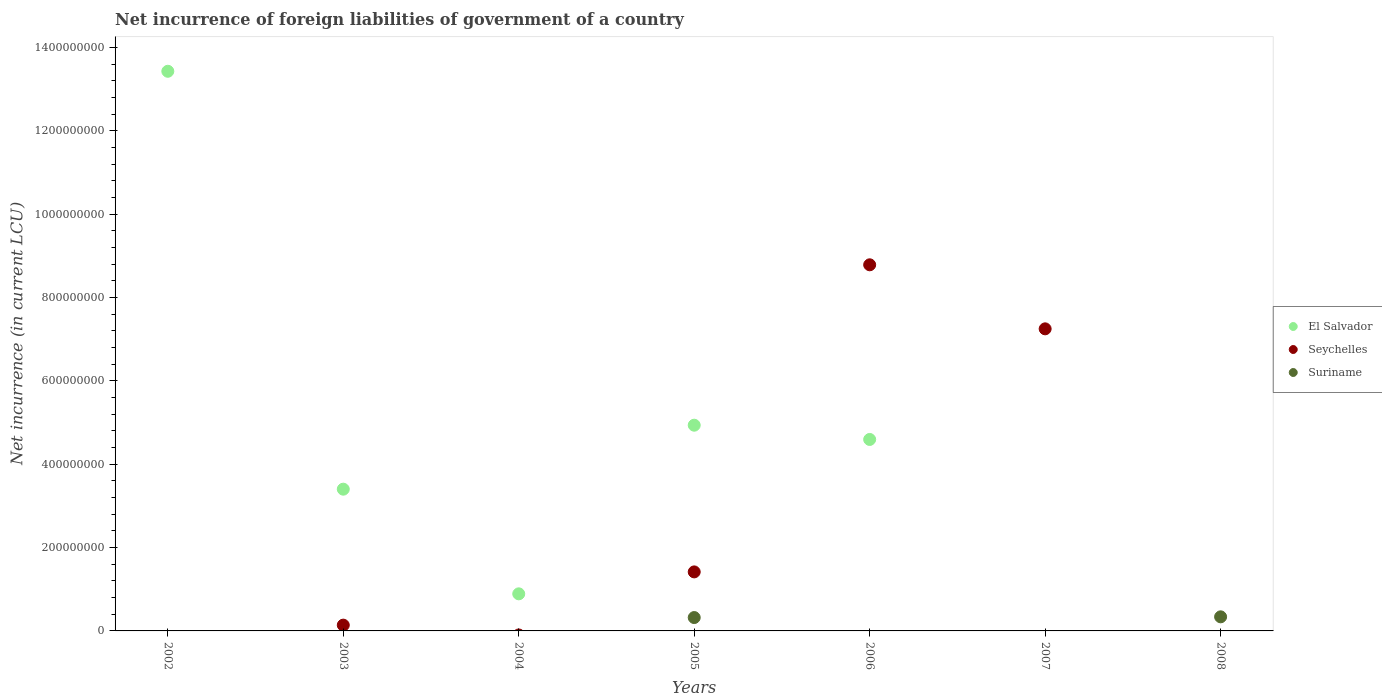Is the number of dotlines equal to the number of legend labels?
Make the answer very short. No. What is the net incurrence of foreign liabilities in Suriname in 2008?
Your answer should be very brief. 3.38e+07. Across all years, what is the maximum net incurrence of foreign liabilities in Seychelles?
Your answer should be compact. 8.78e+08. Across all years, what is the minimum net incurrence of foreign liabilities in Suriname?
Offer a terse response. 0. What is the total net incurrence of foreign liabilities in Seychelles in the graph?
Your response must be concise. 1.76e+09. What is the difference between the net incurrence of foreign liabilities in El Salvador in 2003 and that in 2006?
Provide a succinct answer. -1.19e+08. What is the difference between the net incurrence of foreign liabilities in Suriname in 2006 and the net incurrence of foreign liabilities in El Salvador in 2008?
Provide a short and direct response. 0. What is the average net incurrence of foreign liabilities in El Salvador per year?
Provide a succinct answer. 3.89e+08. In the year 2005, what is the difference between the net incurrence of foreign liabilities in Seychelles and net incurrence of foreign liabilities in Suriname?
Your response must be concise. 1.10e+08. In how many years, is the net incurrence of foreign liabilities in Seychelles greater than 960000000 LCU?
Ensure brevity in your answer.  0. What is the ratio of the net incurrence of foreign liabilities in El Salvador in 2002 to that in 2006?
Provide a succinct answer. 2.92. Is the net incurrence of foreign liabilities in El Salvador in 2003 less than that in 2006?
Ensure brevity in your answer.  Yes. What is the difference between the highest and the second highest net incurrence of foreign liabilities in Seychelles?
Make the answer very short. 1.54e+08. What is the difference between the highest and the lowest net incurrence of foreign liabilities in El Salvador?
Keep it short and to the point. 1.34e+09. In how many years, is the net incurrence of foreign liabilities in Seychelles greater than the average net incurrence of foreign liabilities in Seychelles taken over all years?
Ensure brevity in your answer.  2. Does the net incurrence of foreign liabilities in Seychelles monotonically increase over the years?
Give a very brief answer. No. Is the net incurrence of foreign liabilities in Suriname strictly greater than the net incurrence of foreign liabilities in El Salvador over the years?
Give a very brief answer. No. What is the difference between two consecutive major ticks on the Y-axis?
Make the answer very short. 2.00e+08. Does the graph contain any zero values?
Offer a terse response. Yes. How many legend labels are there?
Your answer should be compact. 3. What is the title of the graph?
Your answer should be compact. Net incurrence of foreign liabilities of government of a country. What is the label or title of the X-axis?
Offer a very short reply. Years. What is the label or title of the Y-axis?
Your answer should be compact. Net incurrence (in current LCU). What is the Net incurrence (in current LCU) of El Salvador in 2002?
Offer a terse response. 1.34e+09. What is the Net incurrence (in current LCU) of El Salvador in 2003?
Keep it short and to the point. 3.40e+08. What is the Net incurrence (in current LCU) in Seychelles in 2003?
Keep it short and to the point. 1.39e+07. What is the Net incurrence (in current LCU) in El Salvador in 2004?
Ensure brevity in your answer.  8.90e+07. What is the Net incurrence (in current LCU) in El Salvador in 2005?
Provide a short and direct response. 4.94e+08. What is the Net incurrence (in current LCU) of Seychelles in 2005?
Your answer should be compact. 1.42e+08. What is the Net incurrence (in current LCU) in Suriname in 2005?
Provide a succinct answer. 3.21e+07. What is the Net incurrence (in current LCU) of El Salvador in 2006?
Ensure brevity in your answer.  4.59e+08. What is the Net incurrence (in current LCU) in Seychelles in 2006?
Offer a very short reply. 8.78e+08. What is the Net incurrence (in current LCU) in El Salvador in 2007?
Your answer should be compact. 0. What is the Net incurrence (in current LCU) in Seychelles in 2007?
Make the answer very short. 7.25e+08. What is the Net incurrence (in current LCU) in Suriname in 2007?
Keep it short and to the point. 0. What is the Net incurrence (in current LCU) of El Salvador in 2008?
Your answer should be very brief. 0. What is the Net incurrence (in current LCU) of Suriname in 2008?
Your response must be concise. 3.38e+07. Across all years, what is the maximum Net incurrence (in current LCU) of El Salvador?
Provide a short and direct response. 1.34e+09. Across all years, what is the maximum Net incurrence (in current LCU) in Seychelles?
Your response must be concise. 8.78e+08. Across all years, what is the maximum Net incurrence (in current LCU) of Suriname?
Make the answer very short. 3.38e+07. Across all years, what is the minimum Net incurrence (in current LCU) of El Salvador?
Ensure brevity in your answer.  0. Across all years, what is the minimum Net incurrence (in current LCU) in Suriname?
Make the answer very short. 0. What is the total Net incurrence (in current LCU) of El Salvador in the graph?
Your response must be concise. 2.72e+09. What is the total Net incurrence (in current LCU) in Seychelles in the graph?
Your response must be concise. 1.76e+09. What is the total Net incurrence (in current LCU) of Suriname in the graph?
Make the answer very short. 6.59e+07. What is the difference between the Net incurrence (in current LCU) of El Salvador in 2002 and that in 2003?
Ensure brevity in your answer.  1.00e+09. What is the difference between the Net incurrence (in current LCU) in El Salvador in 2002 and that in 2004?
Your answer should be very brief. 1.25e+09. What is the difference between the Net incurrence (in current LCU) of El Salvador in 2002 and that in 2005?
Provide a succinct answer. 8.49e+08. What is the difference between the Net incurrence (in current LCU) of El Salvador in 2002 and that in 2006?
Provide a succinct answer. 8.83e+08. What is the difference between the Net incurrence (in current LCU) of El Salvador in 2003 and that in 2004?
Your answer should be very brief. 2.51e+08. What is the difference between the Net incurrence (in current LCU) in El Salvador in 2003 and that in 2005?
Your answer should be very brief. -1.54e+08. What is the difference between the Net incurrence (in current LCU) in Seychelles in 2003 and that in 2005?
Make the answer very short. -1.28e+08. What is the difference between the Net incurrence (in current LCU) of El Salvador in 2003 and that in 2006?
Your response must be concise. -1.19e+08. What is the difference between the Net incurrence (in current LCU) in Seychelles in 2003 and that in 2006?
Give a very brief answer. -8.65e+08. What is the difference between the Net incurrence (in current LCU) of Seychelles in 2003 and that in 2007?
Provide a short and direct response. -7.11e+08. What is the difference between the Net incurrence (in current LCU) of El Salvador in 2004 and that in 2005?
Give a very brief answer. -4.05e+08. What is the difference between the Net incurrence (in current LCU) in El Salvador in 2004 and that in 2006?
Make the answer very short. -3.70e+08. What is the difference between the Net incurrence (in current LCU) of El Salvador in 2005 and that in 2006?
Give a very brief answer. 3.42e+07. What is the difference between the Net incurrence (in current LCU) of Seychelles in 2005 and that in 2006?
Your response must be concise. -7.37e+08. What is the difference between the Net incurrence (in current LCU) in Seychelles in 2005 and that in 2007?
Provide a succinct answer. -5.83e+08. What is the difference between the Net incurrence (in current LCU) of Suriname in 2005 and that in 2008?
Provide a short and direct response. -1.72e+06. What is the difference between the Net incurrence (in current LCU) in Seychelles in 2006 and that in 2007?
Offer a very short reply. 1.54e+08. What is the difference between the Net incurrence (in current LCU) of El Salvador in 2002 and the Net incurrence (in current LCU) of Seychelles in 2003?
Your answer should be compact. 1.33e+09. What is the difference between the Net incurrence (in current LCU) of El Salvador in 2002 and the Net incurrence (in current LCU) of Seychelles in 2005?
Keep it short and to the point. 1.20e+09. What is the difference between the Net incurrence (in current LCU) in El Salvador in 2002 and the Net incurrence (in current LCU) in Suriname in 2005?
Your response must be concise. 1.31e+09. What is the difference between the Net incurrence (in current LCU) of El Salvador in 2002 and the Net incurrence (in current LCU) of Seychelles in 2006?
Provide a succinct answer. 4.64e+08. What is the difference between the Net incurrence (in current LCU) in El Salvador in 2002 and the Net incurrence (in current LCU) in Seychelles in 2007?
Make the answer very short. 6.18e+08. What is the difference between the Net incurrence (in current LCU) of El Salvador in 2002 and the Net incurrence (in current LCU) of Suriname in 2008?
Offer a terse response. 1.31e+09. What is the difference between the Net incurrence (in current LCU) in El Salvador in 2003 and the Net incurrence (in current LCU) in Seychelles in 2005?
Your response must be concise. 1.98e+08. What is the difference between the Net incurrence (in current LCU) in El Salvador in 2003 and the Net incurrence (in current LCU) in Suriname in 2005?
Offer a very short reply. 3.08e+08. What is the difference between the Net incurrence (in current LCU) of Seychelles in 2003 and the Net incurrence (in current LCU) of Suriname in 2005?
Offer a very short reply. -1.82e+07. What is the difference between the Net incurrence (in current LCU) in El Salvador in 2003 and the Net incurrence (in current LCU) in Seychelles in 2006?
Ensure brevity in your answer.  -5.38e+08. What is the difference between the Net incurrence (in current LCU) of El Salvador in 2003 and the Net incurrence (in current LCU) of Seychelles in 2007?
Offer a very short reply. -3.85e+08. What is the difference between the Net incurrence (in current LCU) of El Salvador in 2003 and the Net incurrence (in current LCU) of Suriname in 2008?
Give a very brief answer. 3.06e+08. What is the difference between the Net incurrence (in current LCU) in Seychelles in 2003 and the Net incurrence (in current LCU) in Suriname in 2008?
Make the answer very short. -1.99e+07. What is the difference between the Net incurrence (in current LCU) of El Salvador in 2004 and the Net incurrence (in current LCU) of Seychelles in 2005?
Ensure brevity in your answer.  -5.26e+07. What is the difference between the Net incurrence (in current LCU) in El Salvador in 2004 and the Net incurrence (in current LCU) in Suriname in 2005?
Ensure brevity in your answer.  5.69e+07. What is the difference between the Net incurrence (in current LCU) in El Salvador in 2004 and the Net incurrence (in current LCU) in Seychelles in 2006?
Your response must be concise. -7.89e+08. What is the difference between the Net incurrence (in current LCU) in El Salvador in 2004 and the Net incurrence (in current LCU) in Seychelles in 2007?
Give a very brief answer. -6.36e+08. What is the difference between the Net incurrence (in current LCU) of El Salvador in 2004 and the Net incurrence (in current LCU) of Suriname in 2008?
Your answer should be very brief. 5.52e+07. What is the difference between the Net incurrence (in current LCU) in El Salvador in 2005 and the Net incurrence (in current LCU) in Seychelles in 2006?
Offer a very short reply. -3.85e+08. What is the difference between the Net incurrence (in current LCU) in El Salvador in 2005 and the Net incurrence (in current LCU) in Seychelles in 2007?
Give a very brief answer. -2.31e+08. What is the difference between the Net incurrence (in current LCU) in El Salvador in 2005 and the Net incurrence (in current LCU) in Suriname in 2008?
Your answer should be compact. 4.60e+08. What is the difference between the Net incurrence (in current LCU) of Seychelles in 2005 and the Net incurrence (in current LCU) of Suriname in 2008?
Make the answer very short. 1.08e+08. What is the difference between the Net incurrence (in current LCU) in El Salvador in 2006 and the Net incurrence (in current LCU) in Seychelles in 2007?
Give a very brief answer. -2.65e+08. What is the difference between the Net incurrence (in current LCU) in El Salvador in 2006 and the Net incurrence (in current LCU) in Suriname in 2008?
Keep it short and to the point. 4.26e+08. What is the difference between the Net incurrence (in current LCU) of Seychelles in 2006 and the Net incurrence (in current LCU) of Suriname in 2008?
Offer a very short reply. 8.45e+08. What is the difference between the Net incurrence (in current LCU) in Seychelles in 2007 and the Net incurrence (in current LCU) in Suriname in 2008?
Your answer should be very brief. 6.91e+08. What is the average Net incurrence (in current LCU) in El Salvador per year?
Provide a short and direct response. 3.89e+08. What is the average Net incurrence (in current LCU) in Seychelles per year?
Provide a succinct answer. 2.51e+08. What is the average Net incurrence (in current LCU) of Suriname per year?
Ensure brevity in your answer.  9.41e+06. In the year 2003, what is the difference between the Net incurrence (in current LCU) of El Salvador and Net incurrence (in current LCU) of Seychelles?
Your answer should be compact. 3.26e+08. In the year 2005, what is the difference between the Net incurrence (in current LCU) of El Salvador and Net incurrence (in current LCU) of Seychelles?
Give a very brief answer. 3.52e+08. In the year 2005, what is the difference between the Net incurrence (in current LCU) of El Salvador and Net incurrence (in current LCU) of Suriname?
Provide a short and direct response. 4.62e+08. In the year 2005, what is the difference between the Net incurrence (in current LCU) in Seychelles and Net incurrence (in current LCU) in Suriname?
Your response must be concise. 1.10e+08. In the year 2006, what is the difference between the Net incurrence (in current LCU) in El Salvador and Net incurrence (in current LCU) in Seychelles?
Provide a succinct answer. -4.19e+08. What is the ratio of the Net incurrence (in current LCU) in El Salvador in 2002 to that in 2003?
Provide a short and direct response. 3.95. What is the ratio of the Net incurrence (in current LCU) of El Salvador in 2002 to that in 2004?
Provide a succinct answer. 15.09. What is the ratio of the Net incurrence (in current LCU) of El Salvador in 2002 to that in 2005?
Offer a very short reply. 2.72. What is the ratio of the Net incurrence (in current LCU) of El Salvador in 2002 to that in 2006?
Your answer should be very brief. 2.92. What is the ratio of the Net incurrence (in current LCU) of El Salvador in 2003 to that in 2004?
Keep it short and to the point. 3.82. What is the ratio of the Net incurrence (in current LCU) of El Salvador in 2003 to that in 2005?
Make the answer very short. 0.69. What is the ratio of the Net incurrence (in current LCU) in Seychelles in 2003 to that in 2005?
Give a very brief answer. 0.1. What is the ratio of the Net incurrence (in current LCU) in El Salvador in 2003 to that in 2006?
Keep it short and to the point. 0.74. What is the ratio of the Net incurrence (in current LCU) in Seychelles in 2003 to that in 2006?
Keep it short and to the point. 0.02. What is the ratio of the Net incurrence (in current LCU) of Seychelles in 2003 to that in 2007?
Your answer should be very brief. 0.02. What is the ratio of the Net incurrence (in current LCU) in El Salvador in 2004 to that in 2005?
Make the answer very short. 0.18. What is the ratio of the Net incurrence (in current LCU) of El Salvador in 2004 to that in 2006?
Provide a short and direct response. 0.19. What is the ratio of the Net incurrence (in current LCU) of El Salvador in 2005 to that in 2006?
Your response must be concise. 1.07. What is the ratio of the Net incurrence (in current LCU) of Seychelles in 2005 to that in 2006?
Make the answer very short. 0.16. What is the ratio of the Net incurrence (in current LCU) in Seychelles in 2005 to that in 2007?
Provide a short and direct response. 0.2. What is the ratio of the Net incurrence (in current LCU) of Suriname in 2005 to that in 2008?
Provide a short and direct response. 0.95. What is the ratio of the Net incurrence (in current LCU) of Seychelles in 2006 to that in 2007?
Give a very brief answer. 1.21. What is the difference between the highest and the second highest Net incurrence (in current LCU) of El Salvador?
Ensure brevity in your answer.  8.49e+08. What is the difference between the highest and the second highest Net incurrence (in current LCU) of Seychelles?
Your response must be concise. 1.54e+08. What is the difference between the highest and the lowest Net incurrence (in current LCU) in El Salvador?
Your response must be concise. 1.34e+09. What is the difference between the highest and the lowest Net incurrence (in current LCU) in Seychelles?
Make the answer very short. 8.78e+08. What is the difference between the highest and the lowest Net incurrence (in current LCU) of Suriname?
Provide a short and direct response. 3.38e+07. 